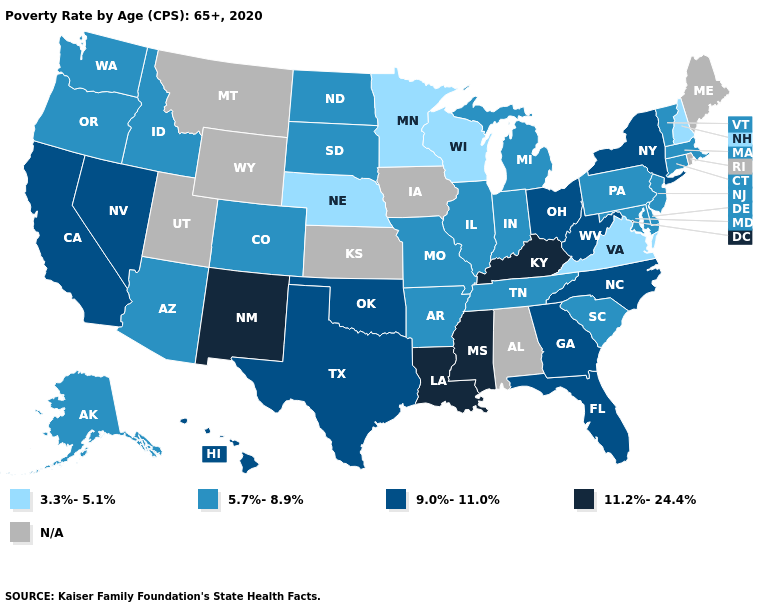What is the value of Washington?
Short answer required. 5.7%-8.9%. Which states have the lowest value in the USA?
Write a very short answer. Minnesota, Nebraska, New Hampshire, Virginia, Wisconsin. What is the value of Nebraska?
Be succinct. 3.3%-5.1%. Does the map have missing data?
Concise answer only. Yes. Name the states that have a value in the range 3.3%-5.1%?
Quick response, please. Minnesota, Nebraska, New Hampshire, Virginia, Wisconsin. What is the highest value in the USA?
Short answer required. 11.2%-24.4%. Name the states that have a value in the range 3.3%-5.1%?
Write a very short answer. Minnesota, Nebraska, New Hampshire, Virginia, Wisconsin. Among the states that border Nevada , which have the highest value?
Be succinct. California. Does Tennessee have the highest value in the South?
Be succinct. No. Does Virginia have the highest value in the USA?
Quick response, please. No. Which states have the lowest value in the USA?
Write a very short answer. Minnesota, Nebraska, New Hampshire, Virginia, Wisconsin. Does the first symbol in the legend represent the smallest category?
Give a very brief answer. Yes. 